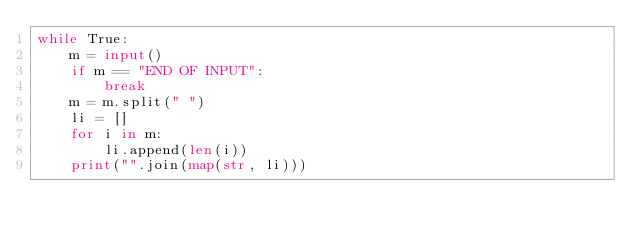Convert code to text. <code><loc_0><loc_0><loc_500><loc_500><_Python_>while True:
    m = input()
    if m == "END OF INPUT":
        break
    m = m.split(" ")
    li = []
    for i in m:
        li.append(len(i))
    print("".join(map(str, li)))
</code> 